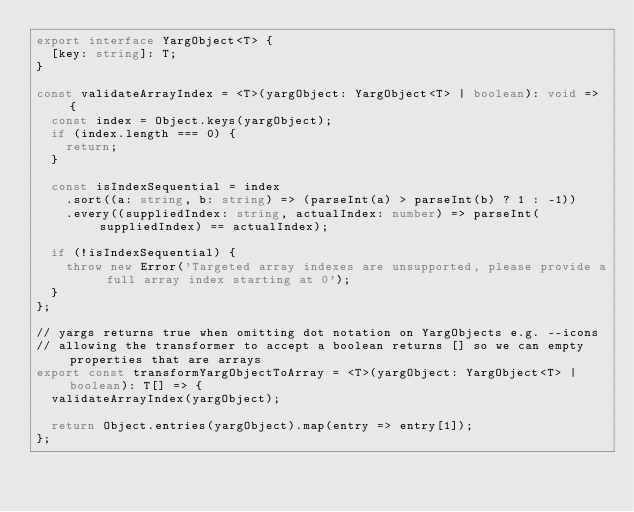Convert code to text. <code><loc_0><loc_0><loc_500><loc_500><_TypeScript_>export interface YargObject<T> {
  [key: string]: T;
}

const validateArrayIndex = <T>(yargObject: YargObject<T> | boolean): void => {
  const index = Object.keys(yargObject);
  if (index.length === 0) {
    return;
  }

  const isIndexSequential = index
    .sort((a: string, b: string) => (parseInt(a) > parseInt(b) ? 1 : -1))
    .every((suppliedIndex: string, actualIndex: number) => parseInt(suppliedIndex) == actualIndex);

  if (!isIndexSequential) {
    throw new Error('Targeted array indexes are unsupported, please provide a full array index starting at 0');
  }
};

// yargs returns true when omitting dot notation on YargObjects e.g. --icons
// allowing the transformer to accept a boolean returns [] so we can empty properties that are arrays
export const transformYargObjectToArray = <T>(yargObject: YargObject<T> | boolean): T[] => {
  validateArrayIndex(yargObject);

  return Object.entries(yargObject).map(entry => entry[1]);
};
</code> 